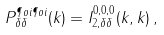<formula> <loc_0><loc_0><loc_500><loc_500>P _ { \delta \delta } ^ { \P o i \P o i } ( k ) = I _ { 2 , \delta \delta } ^ { 0 , 0 , 0 } ( k , k ) \, ,</formula> 